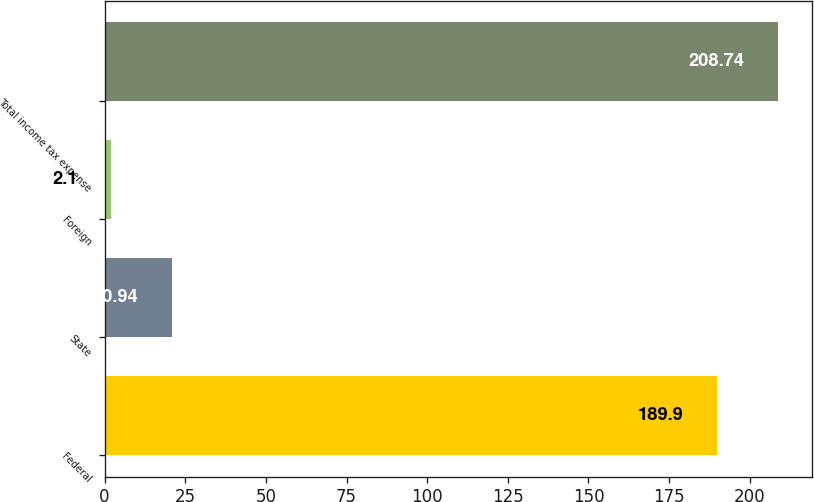Convert chart. <chart><loc_0><loc_0><loc_500><loc_500><bar_chart><fcel>Federal<fcel>State<fcel>Foreign<fcel>Total income tax expense<nl><fcel>189.9<fcel>20.94<fcel>2.1<fcel>208.74<nl></chart> 